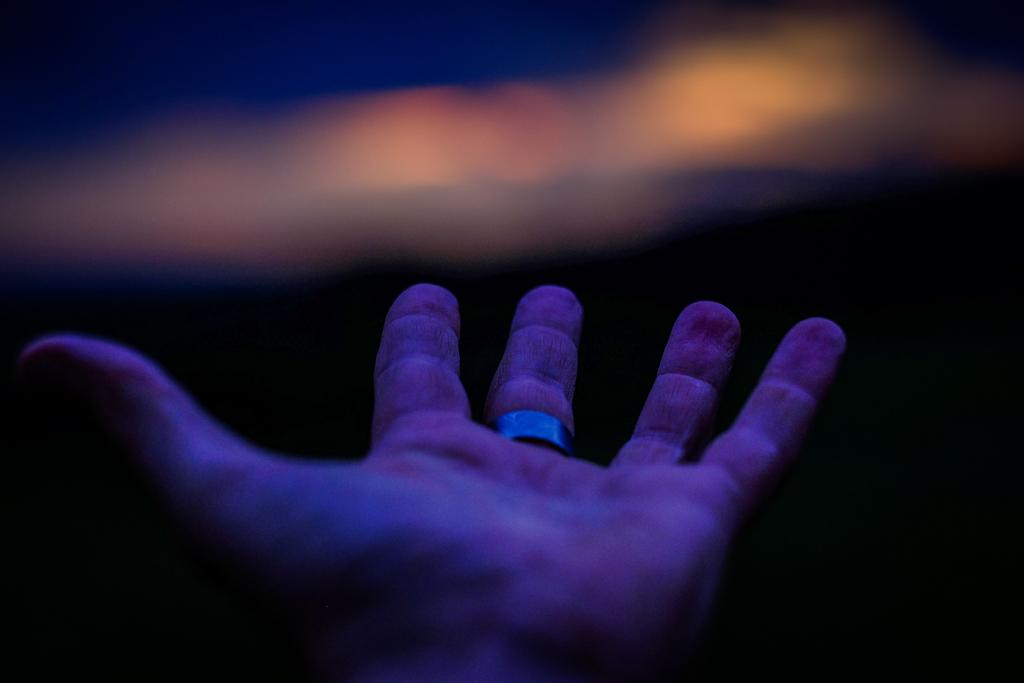What part of a person is visible in the image? There is a hand of a person in the image. What is on the middle finger of the hand? There is a ring on the middle finger of the hand. What type of paste is being used to decorate the flowers in the image? There are no flowers or paste present in the image; it only features a hand with a ring on the middle finger. 